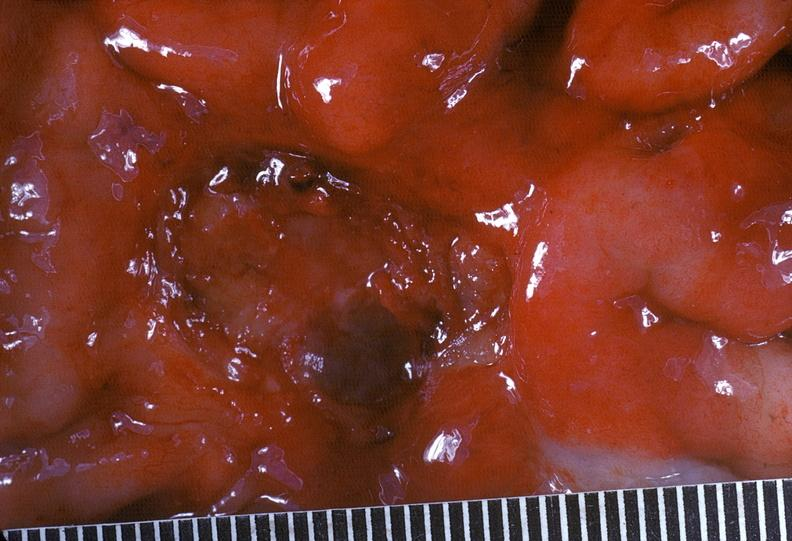what does this image show?
Answer the question using a single word or phrase. Stomach 